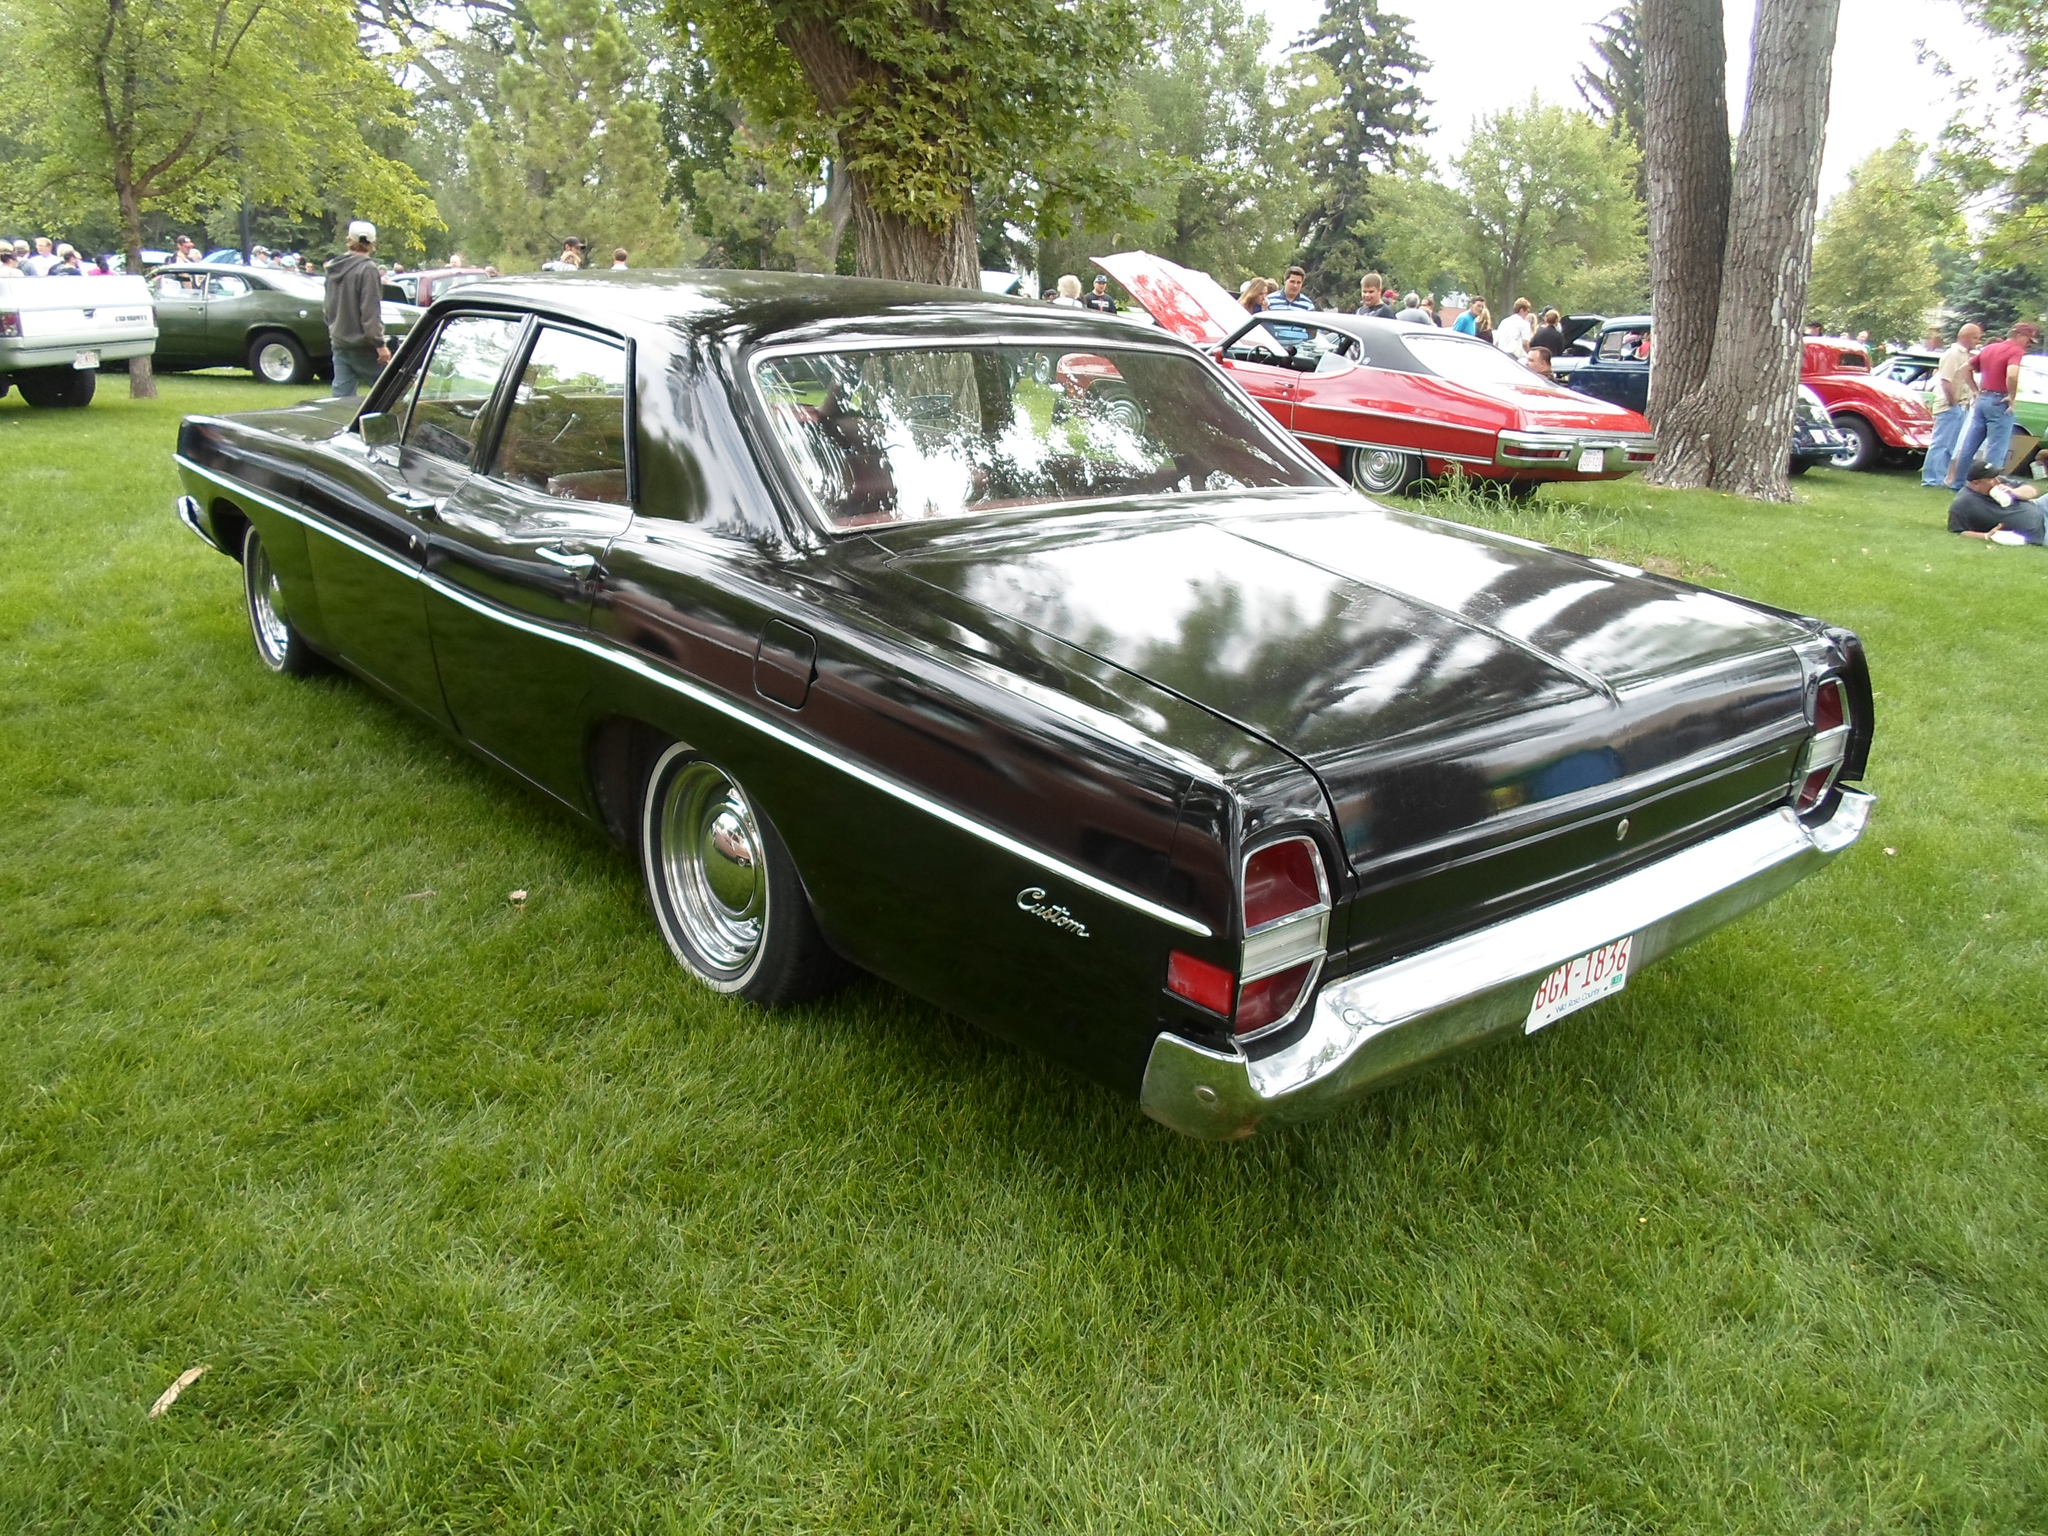Could you give a brief overview of what you see in this image? In the picture we can see a grass surface on it, we can see many vintage cars which are parked on the grass surface and near it, we can see some people are standing and watching them and we can also see some trees and a part of the sky. 